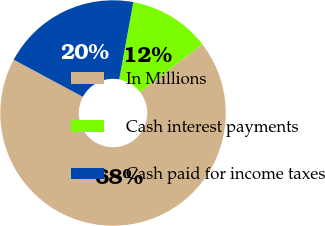Convert chart to OTSL. <chart><loc_0><loc_0><loc_500><loc_500><pie_chart><fcel>In Millions<fcel>Cash interest payments<fcel>Cash paid for income taxes<nl><fcel>68.28%<fcel>11.68%<fcel>20.04%<nl></chart> 